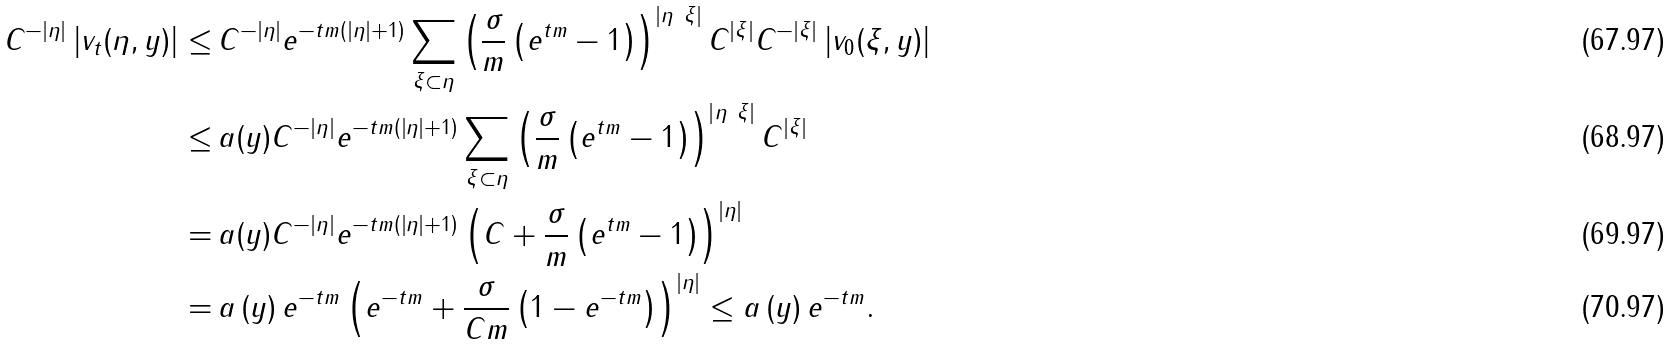Convert formula to latex. <formula><loc_0><loc_0><loc_500><loc_500>C ^ { - | \eta | } \left | v _ { t } ( \eta , y ) \right | \leq & \, C ^ { - | \eta | } e ^ { - t m ( \left | \eta \right | + 1 ) } \sum _ { \xi \subset \eta } \left ( \frac { \sigma } { m } \left ( e ^ { t m } - 1 \right ) \right ) ^ { \left | \eta \ \xi \right | } C ^ { | \xi | } C ^ { - | \xi | } \left | v _ { 0 } ( \xi , y ) \right | \\ \leq & \, a ( y ) C ^ { - | \eta | } e ^ { - t m ( \left | \eta \right | + 1 ) } \sum _ { \xi \subset \eta } \left ( \frac { \sigma } { m } \left ( e ^ { t m } - 1 \right ) \right ) ^ { \left | \eta \ \xi \right | } C ^ { | \xi | } \\ = & \, a ( y ) C ^ { - | \eta | } e ^ { - t m ( \left | \eta \right | + 1 ) } \left ( C + \frac { \sigma } { m } \left ( e ^ { t m } - 1 \right ) \right ) ^ { \left | \eta \right | } \\ = & \, a \left ( y \right ) e ^ { - t m } \left ( e ^ { - t m } + \frac { \sigma } { C m } \left ( 1 - e ^ { - t m } \right ) \right ) ^ { \left | \eta \right | } \leq a \left ( y \right ) e ^ { - t m } .</formula> 